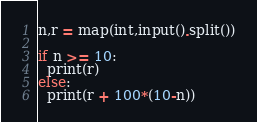Convert code to text. <code><loc_0><loc_0><loc_500><loc_500><_Python_>n,r = map(int,input().split())

if n >= 10:
  print(r)
else:
  print(r + 100*(10-n))</code> 